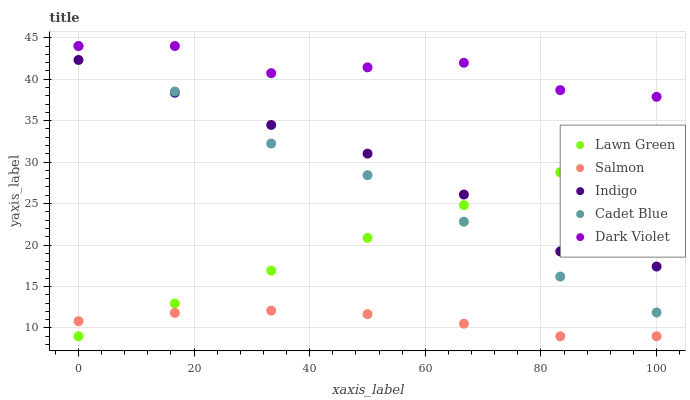Does Salmon have the minimum area under the curve?
Answer yes or no. Yes. Does Dark Violet have the maximum area under the curve?
Answer yes or no. Yes. Does Cadet Blue have the minimum area under the curve?
Answer yes or no. No. Does Cadet Blue have the maximum area under the curve?
Answer yes or no. No. Is Lawn Green the smoothest?
Answer yes or no. Yes. Is Dark Violet the roughest?
Answer yes or no. Yes. Is Cadet Blue the smoothest?
Answer yes or no. No. Is Cadet Blue the roughest?
Answer yes or no. No. Does Lawn Green have the lowest value?
Answer yes or no. Yes. Does Cadet Blue have the lowest value?
Answer yes or no. No. Does Dark Violet have the highest value?
Answer yes or no. Yes. Does Salmon have the highest value?
Answer yes or no. No. Is Salmon less than Dark Violet?
Answer yes or no. Yes. Is Dark Violet greater than Salmon?
Answer yes or no. Yes. Does Cadet Blue intersect Lawn Green?
Answer yes or no. Yes. Is Cadet Blue less than Lawn Green?
Answer yes or no. No. Is Cadet Blue greater than Lawn Green?
Answer yes or no. No. Does Salmon intersect Dark Violet?
Answer yes or no. No. 